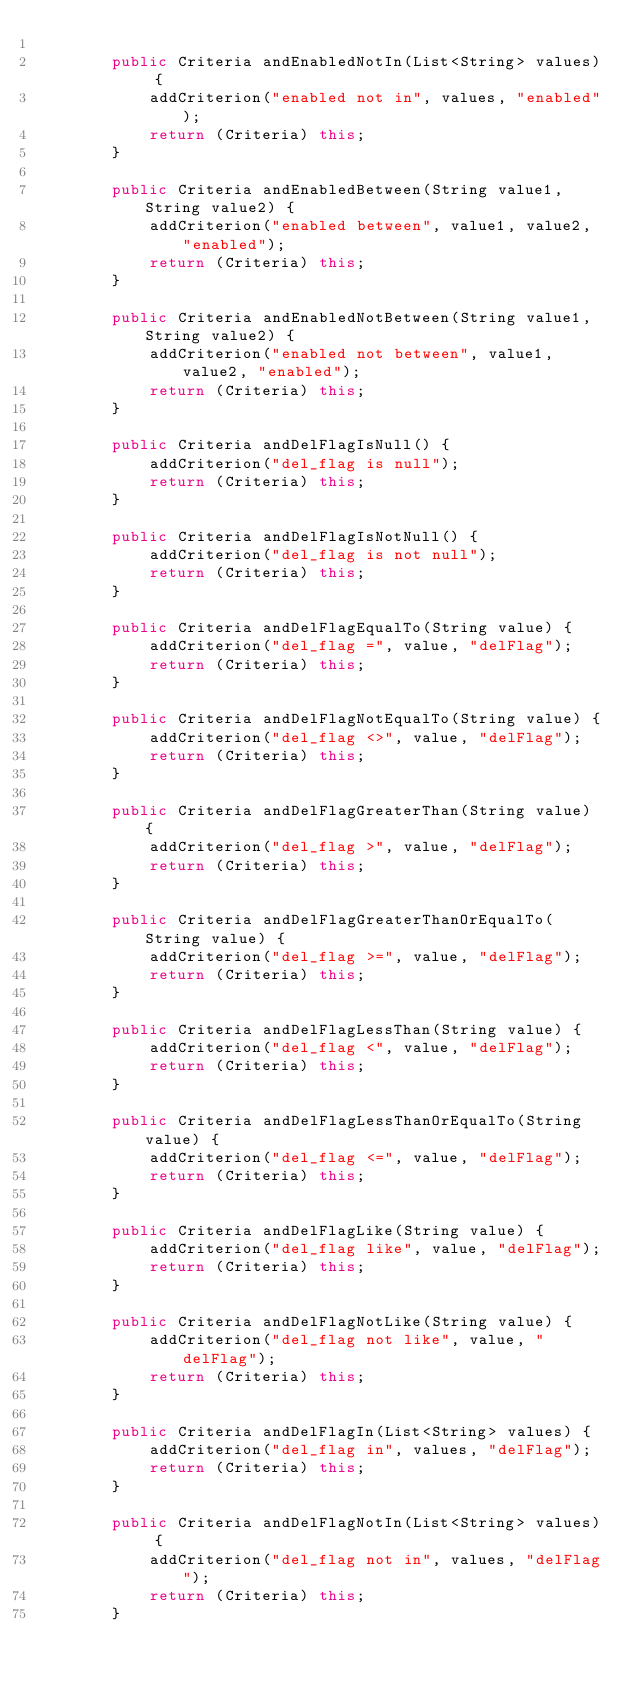Convert code to text. <code><loc_0><loc_0><loc_500><loc_500><_Java_>
        public Criteria andEnabledNotIn(List<String> values) {
            addCriterion("enabled not in", values, "enabled");
            return (Criteria) this;
        }

        public Criteria andEnabledBetween(String value1, String value2) {
            addCriterion("enabled between", value1, value2, "enabled");
            return (Criteria) this;
        }

        public Criteria andEnabledNotBetween(String value1, String value2) {
            addCriterion("enabled not between", value1, value2, "enabled");
            return (Criteria) this;
        }

        public Criteria andDelFlagIsNull() {
            addCriterion("del_flag is null");
            return (Criteria) this;
        }

        public Criteria andDelFlagIsNotNull() {
            addCriterion("del_flag is not null");
            return (Criteria) this;
        }

        public Criteria andDelFlagEqualTo(String value) {
            addCriterion("del_flag =", value, "delFlag");
            return (Criteria) this;
        }

        public Criteria andDelFlagNotEqualTo(String value) {
            addCriterion("del_flag <>", value, "delFlag");
            return (Criteria) this;
        }

        public Criteria andDelFlagGreaterThan(String value) {
            addCriterion("del_flag >", value, "delFlag");
            return (Criteria) this;
        }

        public Criteria andDelFlagGreaterThanOrEqualTo(String value) {
            addCriterion("del_flag >=", value, "delFlag");
            return (Criteria) this;
        }

        public Criteria andDelFlagLessThan(String value) {
            addCriterion("del_flag <", value, "delFlag");
            return (Criteria) this;
        }

        public Criteria andDelFlagLessThanOrEqualTo(String value) {
            addCriterion("del_flag <=", value, "delFlag");
            return (Criteria) this;
        }

        public Criteria andDelFlagLike(String value) {
            addCriterion("del_flag like", value, "delFlag");
            return (Criteria) this;
        }

        public Criteria andDelFlagNotLike(String value) {
            addCriterion("del_flag not like", value, "delFlag");
            return (Criteria) this;
        }

        public Criteria andDelFlagIn(List<String> values) {
            addCriterion("del_flag in", values, "delFlag");
            return (Criteria) this;
        }

        public Criteria andDelFlagNotIn(List<String> values) {
            addCriterion("del_flag not in", values, "delFlag");
            return (Criteria) this;
        }
</code> 